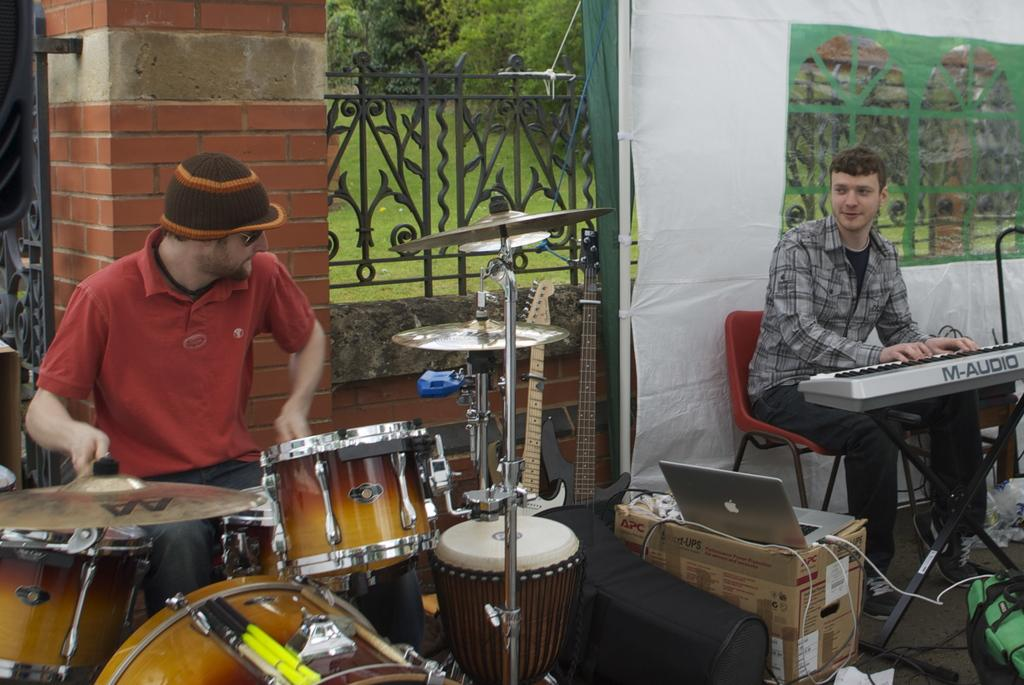What are the people in the image doing? The people in the image are playing drums and a Casio instrument. What type of chairs are the people sitting on? The information provided does not specify the type of chairs the people are sitting on. What else can be seen in the image besides the people playing instruments? There is a laptop on a cardboard box in the image. What type of quilt is being used as a backdrop for the instruments in the image? There is no quilt present in the image. Can you tell me how the people are swinging their instruments in the image? The people are not swinging their instruments in the image; they are playing them. 